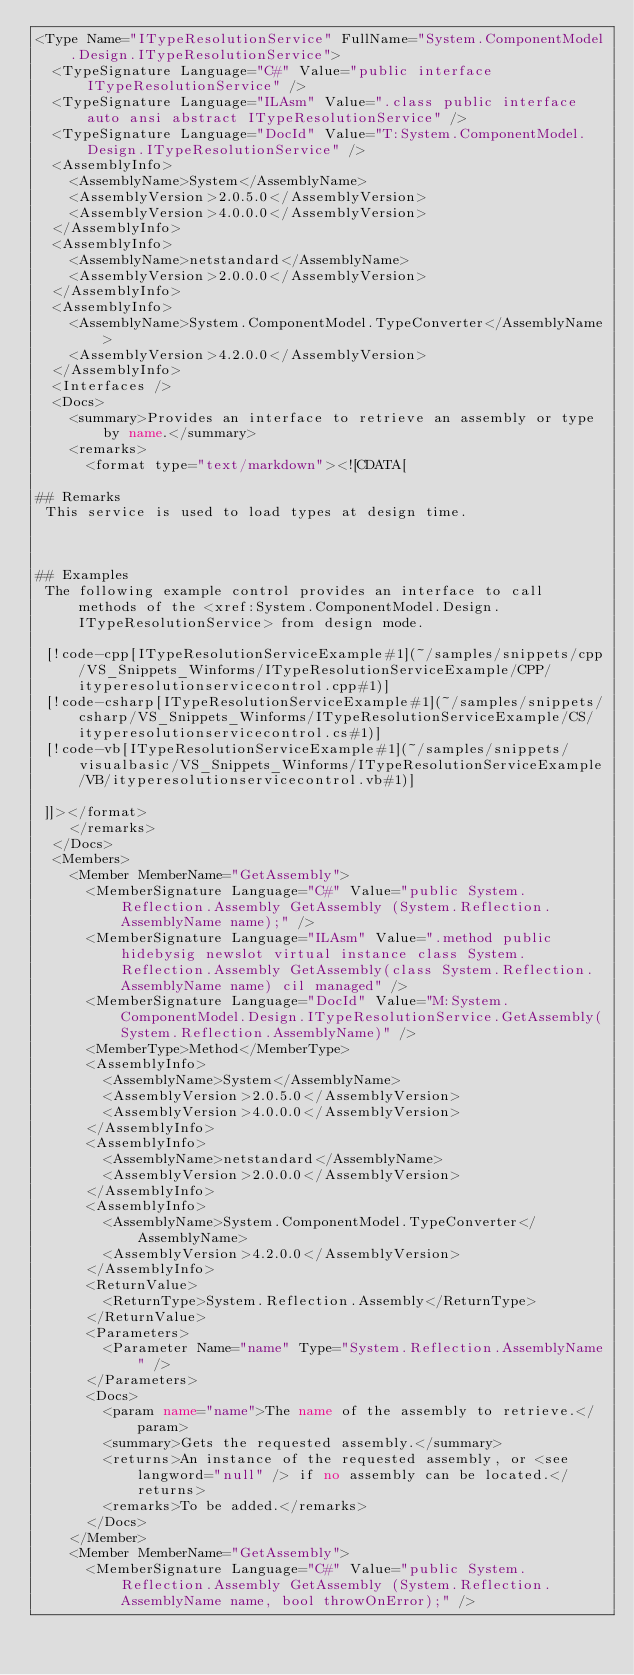Convert code to text. <code><loc_0><loc_0><loc_500><loc_500><_XML_><Type Name="ITypeResolutionService" FullName="System.ComponentModel.Design.ITypeResolutionService">
  <TypeSignature Language="C#" Value="public interface ITypeResolutionService" />
  <TypeSignature Language="ILAsm" Value=".class public interface auto ansi abstract ITypeResolutionService" />
  <TypeSignature Language="DocId" Value="T:System.ComponentModel.Design.ITypeResolutionService" />
  <AssemblyInfo>
    <AssemblyName>System</AssemblyName>
    <AssemblyVersion>2.0.5.0</AssemblyVersion>
    <AssemblyVersion>4.0.0.0</AssemblyVersion>
  </AssemblyInfo>
  <AssemblyInfo>
    <AssemblyName>netstandard</AssemblyName>
    <AssemblyVersion>2.0.0.0</AssemblyVersion>
  </AssemblyInfo>
  <AssemblyInfo>
    <AssemblyName>System.ComponentModel.TypeConverter</AssemblyName>
    <AssemblyVersion>4.2.0.0</AssemblyVersion>
  </AssemblyInfo>
  <Interfaces />
  <Docs>
    <summary>Provides an interface to retrieve an assembly or type by name.</summary>
    <remarks>
      <format type="text/markdown"><![CDATA[  
  
## Remarks  
 This service is used to load types at design time.  
  
   
  
## Examples  
 The following example control provides an interface to call methods of the <xref:System.ComponentModel.Design.ITypeResolutionService> from design mode.  
  
 [!code-cpp[ITypeResolutionServiceExample#1](~/samples/snippets/cpp/VS_Snippets_Winforms/ITypeResolutionServiceExample/CPP/ityperesolutionservicecontrol.cpp#1)]
 [!code-csharp[ITypeResolutionServiceExample#1](~/samples/snippets/csharp/VS_Snippets_Winforms/ITypeResolutionServiceExample/CS/ityperesolutionservicecontrol.cs#1)]
 [!code-vb[ITypeResolutionServiceExample#1](~/samples/snippets/visualbasic/VS_Snippets_Winforms/ITypeResolutionServiceExample/VB/ityperesolutionservicecontrol.vb#1)]  
  
 ]]></format>
    </remarks>
  </Docs>
  <Members>
    <Member MemberName="GetAssembly">
      <MemberSignature Language="C#" Value="public System.Reflection.Assembly GetAssembly (System.Reflection.AssemblyName name);" />
      <MemberSignature Language="ILAsm" Value=".method public hidebysig newslot virtual instance class System.Reflection.Assembly GetAssembly(class System.Reflection.AssemblyName name) cil managed" />
      <MemberSignature Language="DocId" Value="M:System.ComponentModel.Design.ITypeResolutionService.GetAssembly(System.Reflection.AssemblyName)" />
      <MemberType>Method</MemberType>
      <AssemblyInfo>
        <AssemblyName>System</AssemblyName>
        <AssemblyVersion>2.0.5.0</AssemblyVersion>
        <AssemblyVersion>4.0.0.0</AssemblyVersion>
      </AssemblyInfo>
      <AssemblyInfo>
        <AssemblyName>netstandard</AssemblyName>
        <AssemblyVersion>2.0.0.0</AssemblyVersion>
      </AssemblyInfo>
      <AssemblyInfo>
        <AssemblyName>System.ComponentModel.TypeConverter</AssemblyName>
        <AssemblyVersion>4.2.0.0</AssemblyVersion>
      </AssemblyInfo>
      <ReturnValue>
        <ReturnType>System.Reflection.Assembly</ReturnType>
      </ReturnValue>
      <Parameters>
        <Parameter Name="name" Type="System.Reflection.AssemblyName" />
      </Parameters>
      <Docs>
        <param name="name">The name of the assembly to retrieve.</param>
        <summary>Gets the requested assembly.</summary>
        <returns>An instance of the requested assembly, or <see langword="null" /> if no assembly can be located.</returns>
        <remarks>To be added.</remarks>
      </Docs>
    </Member>
    <Member MemberName="GetAssembly">
      <MemberSignature Language="C#" Value="public System.Reflection.Assembly GetAssembly (System.Reflection.AssemblyName name, bool throwOnError);" /></code> 